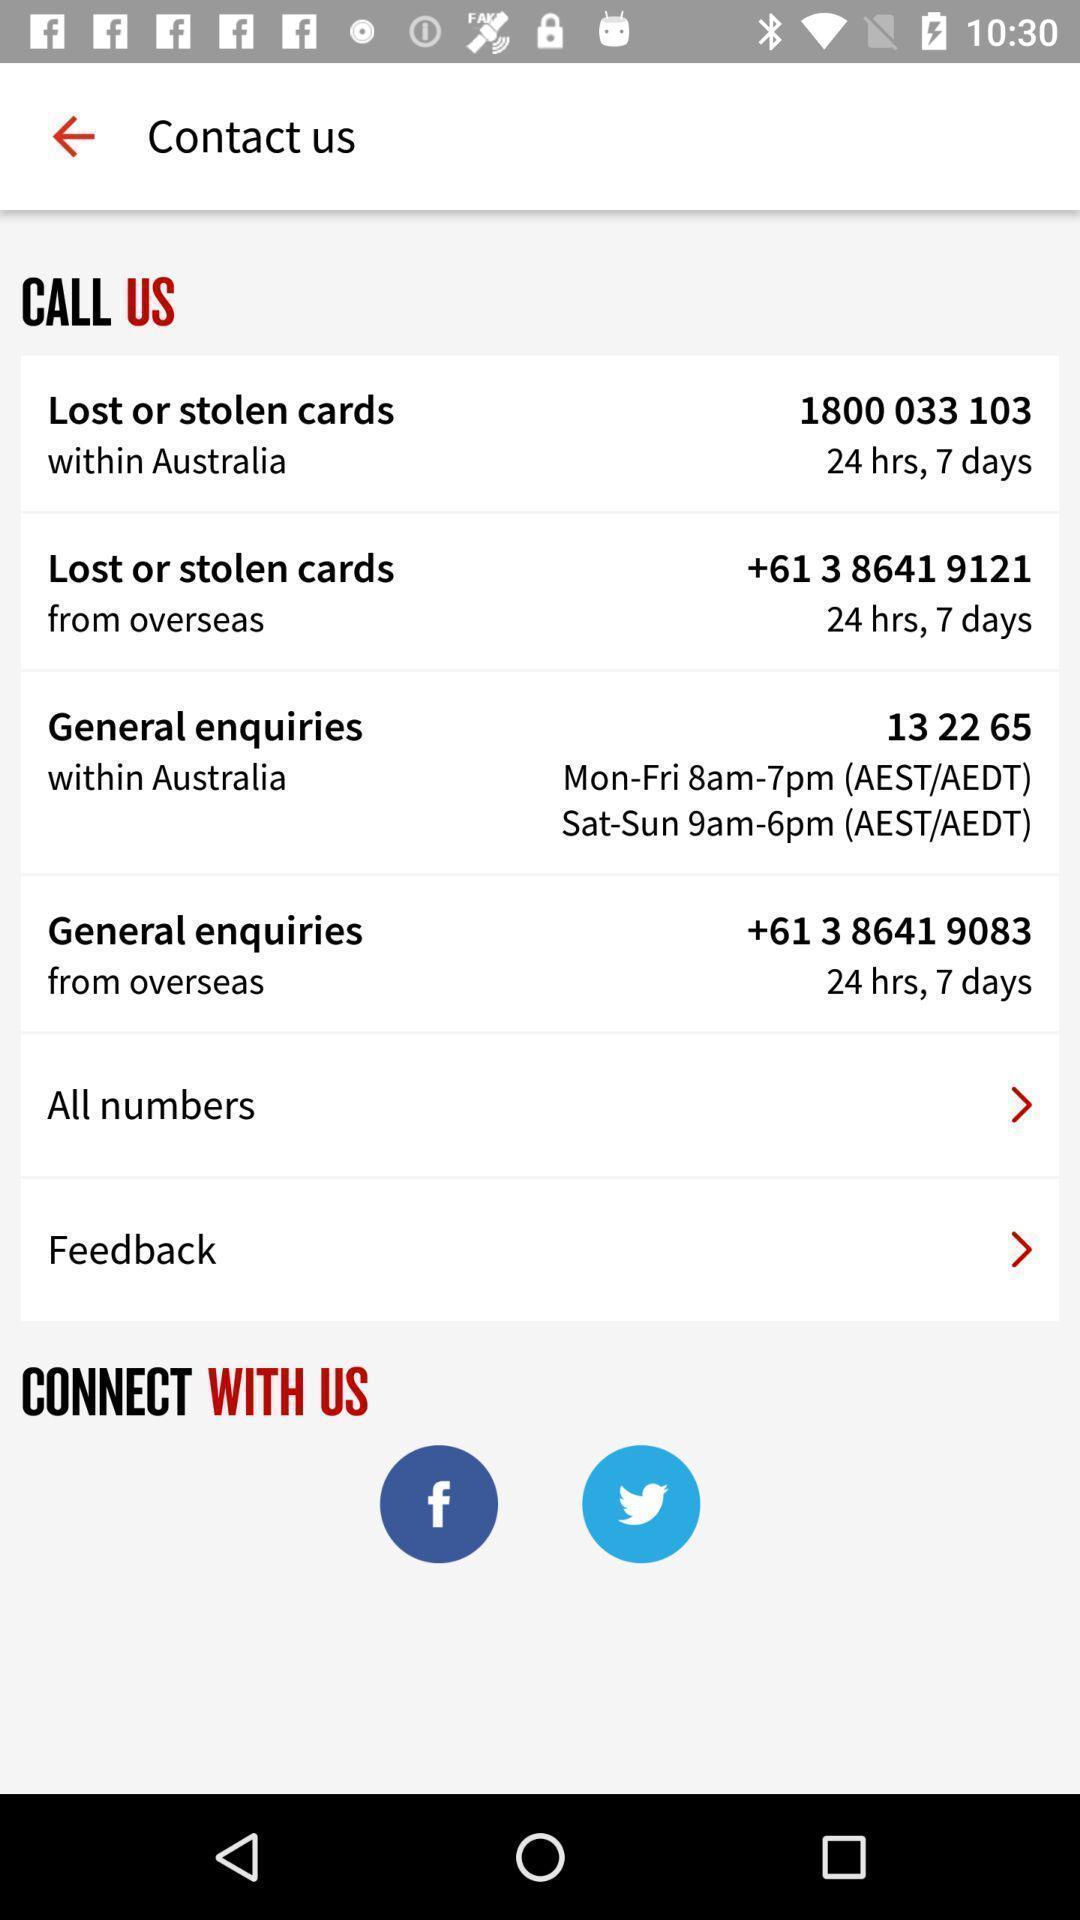Describe the key features of this screenshot. Screen showing contact us details page. 